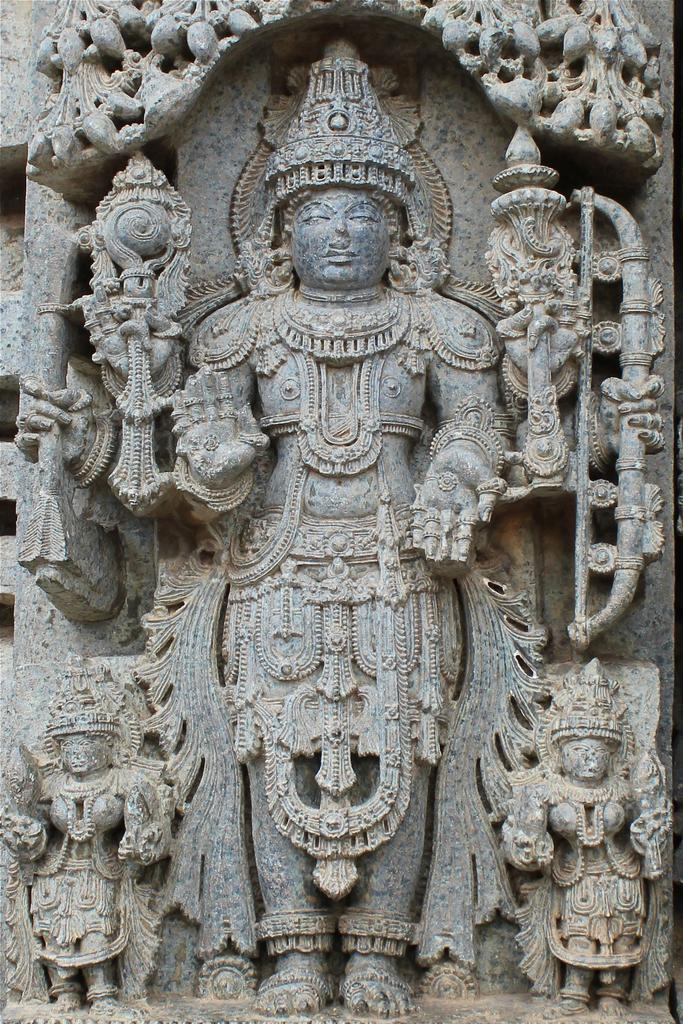What can be seen on the wall in the image? There are sculptures and carvings on the wall in the image. What is the main subject in the middle of the image? There is a sculpture of a god in the middle of the image. Can you describe the style or theme of the sculptures and carvings? Unfortunately, the facts provided do not give enough information to describe the style or theme of the sculptures and carvings. What type of stem can be seen growing from the sculpture of the god in the image? There is no stem present in the image; it features a sculpture of a god and sculptures and carvings on the wall. Is there a volcano visible in the image? No, there is no volcano present in the image. 